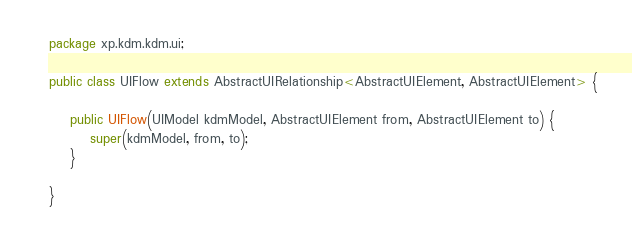Convert code to text. <code><loc_0><loc_0><loc_500><loc_500><_Java_>package xp.kdm.kdm.ui;

public class UIFlow extends AbstractUIRelationship<AbstractUIElement, AbstractUIElement> {

    public UIFlow(UIModel kdmModel, AbstractUIElement from, AbstractUIElement to) {
        super(kdmModel, from, to);
    }

}
</code> 